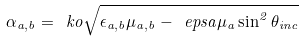Convert formula to latex. <formula><loc_0><loc_0><loc_500><loc_500>\alpha _ { a , b } = \ k o \sqrt { \epsilon _ { a , b } \mu _ { a , b } - \ e p s a \mu _ { a } \sin ^ { 2 } \theta _ { i n c } }</formula> 